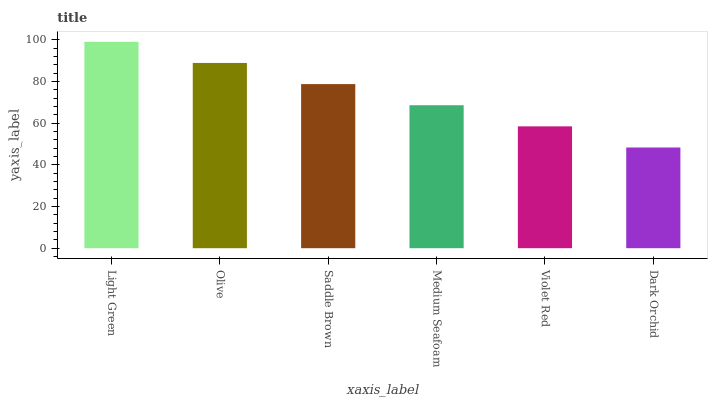Is Dark Orchid the minimum?
Answer yes or no. Yes. Is Light Green the maximum?
Answer yes or no. Yes. Is Olive the minimum?
Answer yes or no. No. Is Olive the maximum?
Answer yes or no. No. Is Light Green greater than Olive?
Answer yes or no. Yes. Is Olive less than Light Green?
Answer yes or no. Yes. Is Olive greater than Light Green?
Answer yes or no. No. Is Light Green less than Olive?
Answer yes or no. No. Is Saddle Brown the high median?
Answer yes or no. Yes. Is Medium Seafoam the low median?
Answer yes or no. Yes. Is Light Green the high median?
Answer yes or no. No. Is Violet Red the low median?
Answer yes or no. No. 